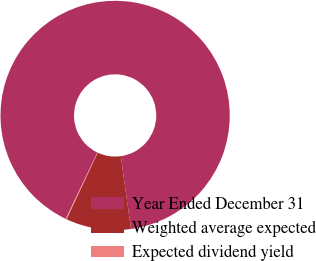<chart> <loc_0><loc_0><loc_500><loc_500><pie_chart><fcel>Year Ended December 31<fcel>Weighted average expected<fcel>Expected dividend yield<nl><fcel>90.7%<fcel>9.18%<fcel>0.12%<nl></chart> 